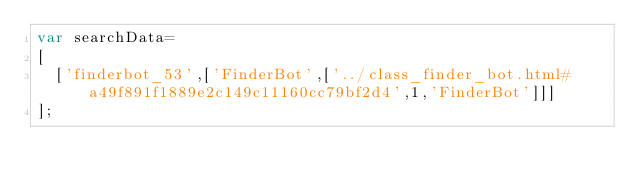<code> <loc_0><loc_0><loc_500><loc_500><_JavaScript_>var searchData=
[
  ['finderbot_53',['FinderBot',['../class_finder_bot.html#a49f891f1889e2c149c11160cc79bf2d4',1,'FinderBot']]]
];
</code> 